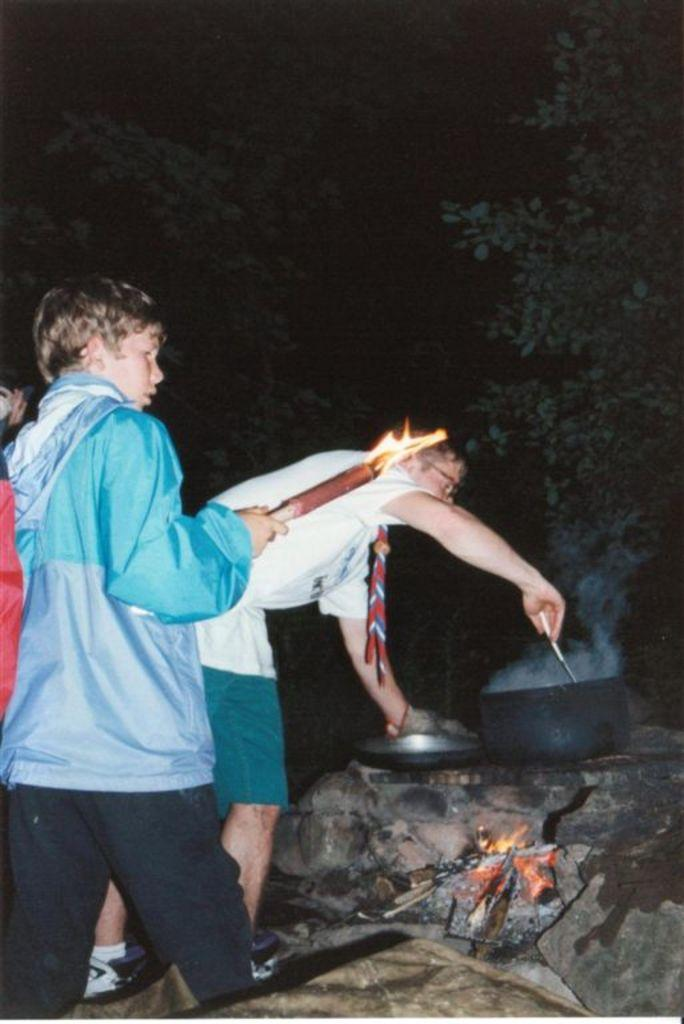What can be seen in the foreground of the image? In the foreground of the image, there are people, stones, a fire, and a vessel. What type of vegetation is visible in the background of the image? Trees can be seen in the background of the image. What is the condition of the sky in the image? The sky is very dark at the top of the image. Where is the office located in the image? There is no office present in the image. What color is the scarf worn by the people in the image? There is no scarf visible in the image; the people are not wearing any clothing mentioned in the facts. 